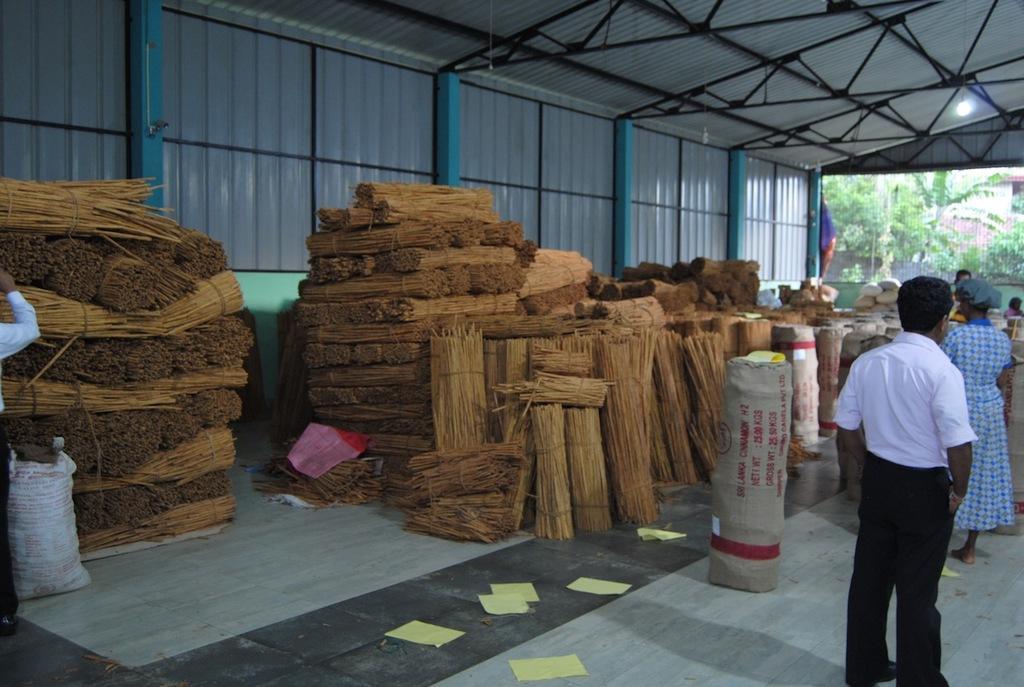Please provide a concise description of this image. In this image we can see a shed. There is a house in the image. There are many plants in the image. There are bundles of sticks in the image. There are few papers on the ground. There are few people at the right side of the image. There is a person at the left side of the image. 